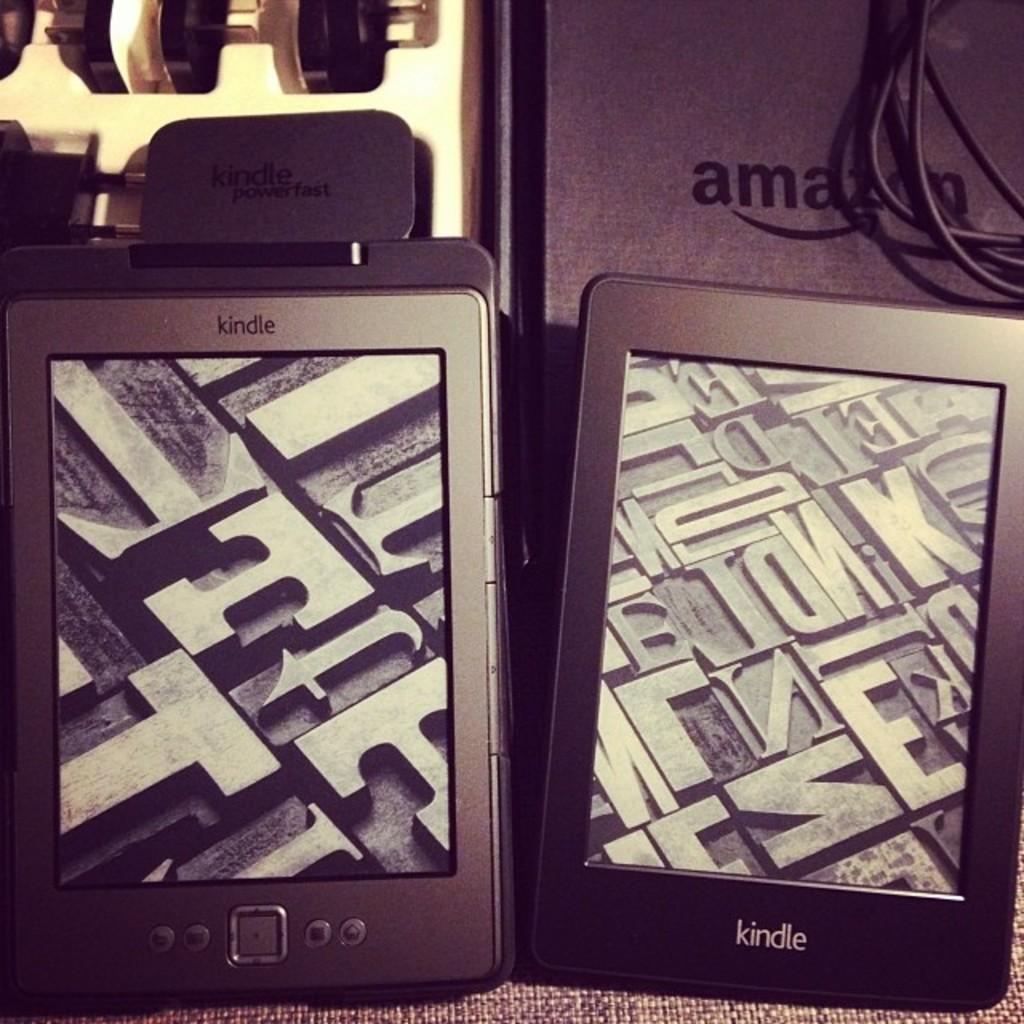<image>
Provide a brief description of the given image. Two Kindle pads from Amazon side by side on mat. 